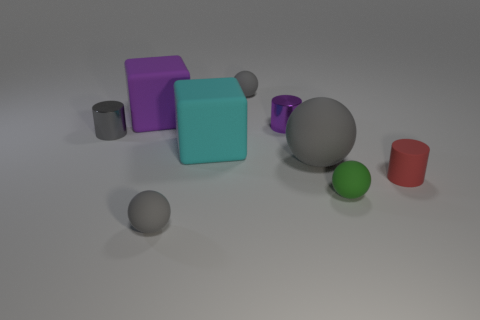How many other rubber balls are the same color as the large sphere?
Offer a very short reply. 2. There is a small rubber object behind the large gray thing; is it the same color as the large rubber sphere?
Make the answer very short. Yes. There is a cyan rubber object; does it have the same size as the shiny cylinder to the right of the purple matte block?
Your answer should be very brief. No. What shape is the gray matte thing behind the matte block in front of the cylinder behind the tiny gray shiny cylinder?
Offer a terse response. Sphere. What material is the purple object on the right side of the small gray rubber object that is in front of the green ball?
Your answer should be compact. Metal. What shape is the big gray object that is made of the same material as the red thing?
Your response must be concise. Sphere. There is a big ball; how many big purple objects are right of it?
Offer a very short reply. 0. Are any matte cubes visible?
Provide a short and direct response. Yes. There is a tiny metal object to the right of the tiny ball that is behind the matte cylinder that is in front of the purple cylinder; what color is it?
Keep it short and to the point. Purple. There is a small gray object behind the big purple block; is there a gray matte thing that is in front of it?
Provide a short and direct response. Yes. 